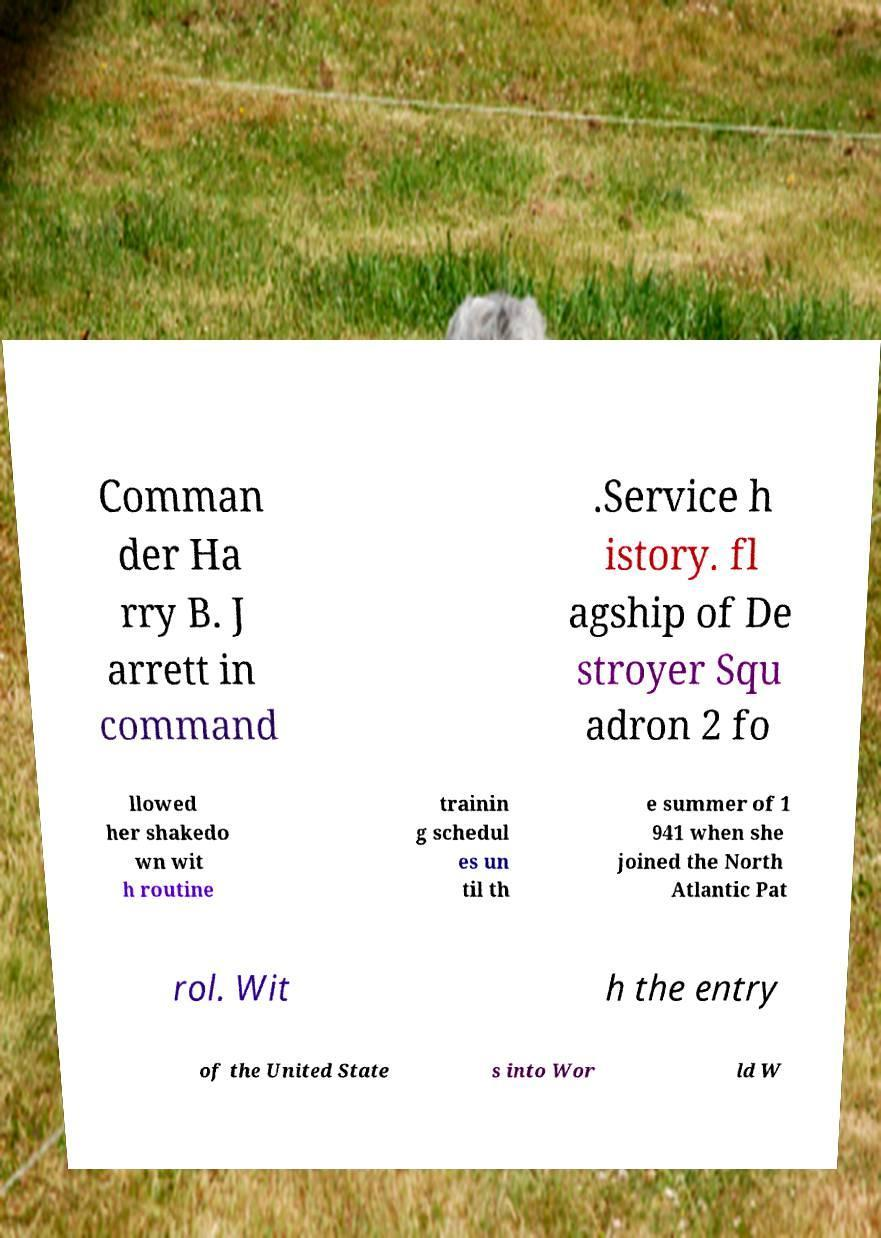Can you accurately transcribe the text from the provided image for me? Comman der Ha rry B. J arrett in command .Service h istory. fl agship of De stroyer Squ adron 2 fo llowed her shakedo wn wit h routine trainin g schedul es un til th e summer of 1 941 when she joined the North Atlantic Pat rol. Wit h the entry of the United State s into Wor ld W 